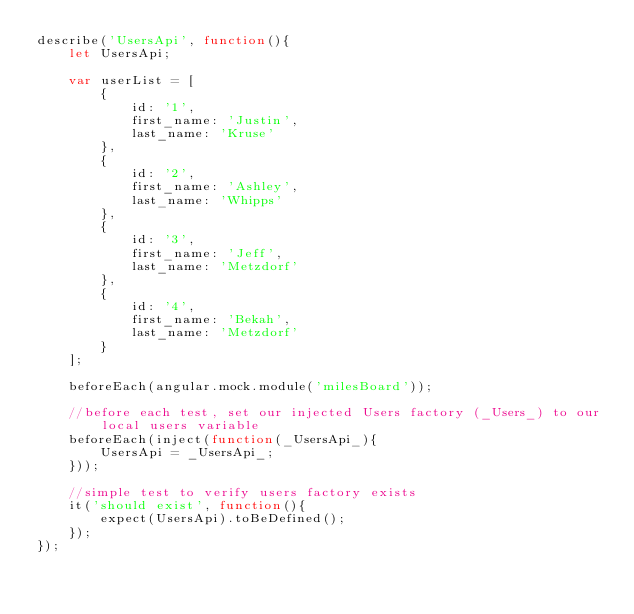Convert code to text. <code><loc_0><loc_0><loc_500><loc_500><_JavaScript_>describe('UsersApi', function(){
    let UsersApi;

    var userList = [
        {
            id: '1',
            first_name: 'Justin',
            last_name: 'Kruse'
        },
        {
            id: '2',
            first_name: 'Ashley',
            last_name: 'Whipps'
        },
        {
            id: '3',
            first_name: 'Jeff',
            last_name: 'Metzdorf'
        },
        {
            id: '4',
            first_name: 'Bekah',
            last_name: 'Metzdorf'
        }
    ];

    beforeEach(angular.mock.module('milesBoard'));

    //before each test, set our injected Users factory (_Users_) to our local users variable
    beforeEach(inject(function(_UsersApi_){
        UsersApi = _UsersApi_;
    }));

    //simple test to verify users factory exists
    it('should exist', function(){
        expect(UsersApi).toBeDefined();
    });
});</code> 